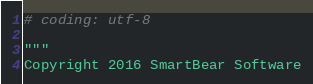Convert code to text. <code><loc_0><loc_0><loc_500><loc_500><_Python_># coding: utf-8

"""
Copyright 2016 SmartBear Software
</code> 